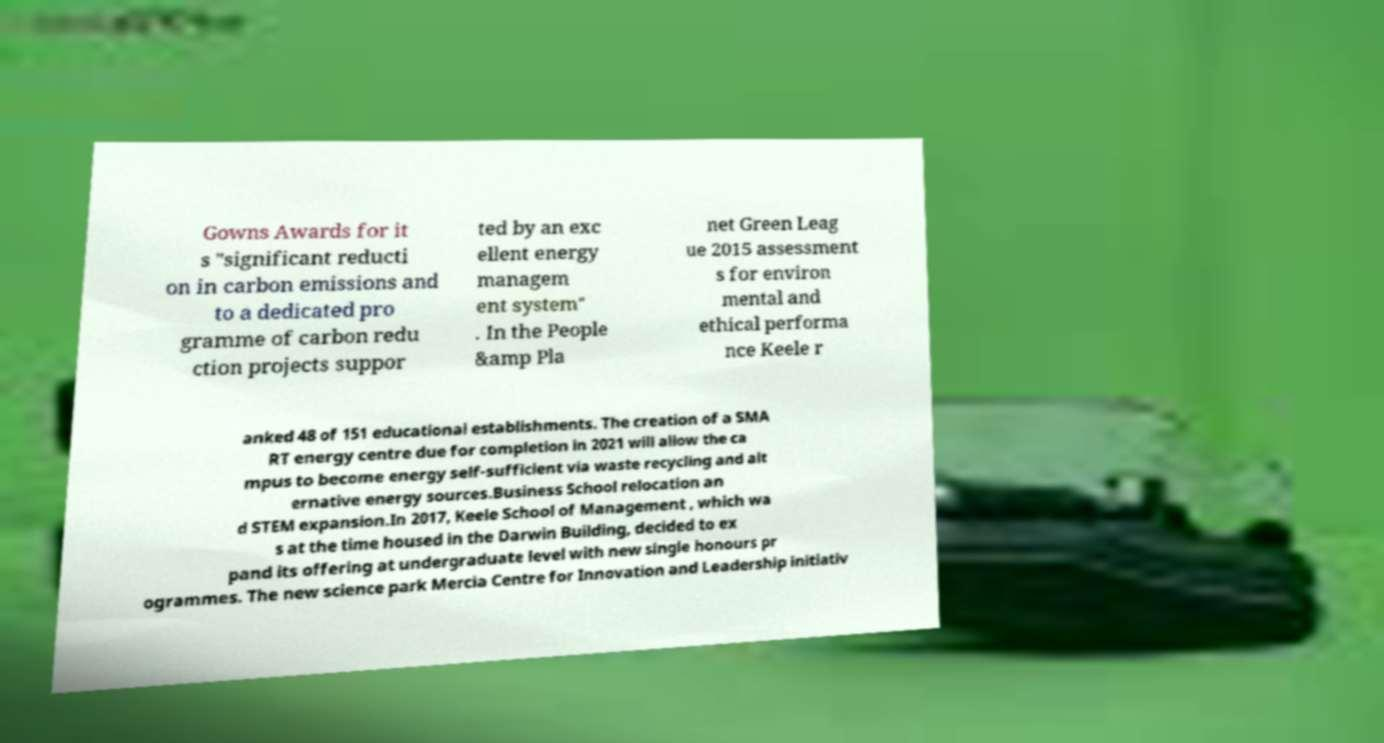Can you read and provide the text displayed in the image?This photo seems to have some interesting text. Can you extract and type it out for me? Gowns Awards for it s "significant reducti on in carbon emissions and to a dedicated pro gramme of carbon redu ction projects suppor ted by an exc ellent energy managem ent system" . In the People &amp Pla net Green Leag ue 2015 assessment s for environ mental and ethical performa nce Keele r anked 48 of 151 educational establishments. The creation of a SMA RT energy centre due for completion in 2021 will allow the ca mpus to become energy self-sufficient via waste recycling and alt ernative energy sources.Business School relocation an d STEM expansion.In 2017, Keele School of Management , which wa s at the time housed in the Darwin Building, decided to ex pand its offering at undergraduate level with new single honours pr ogrammes. The new science park Mercia Centre for Innovation and Leadership initiativ 